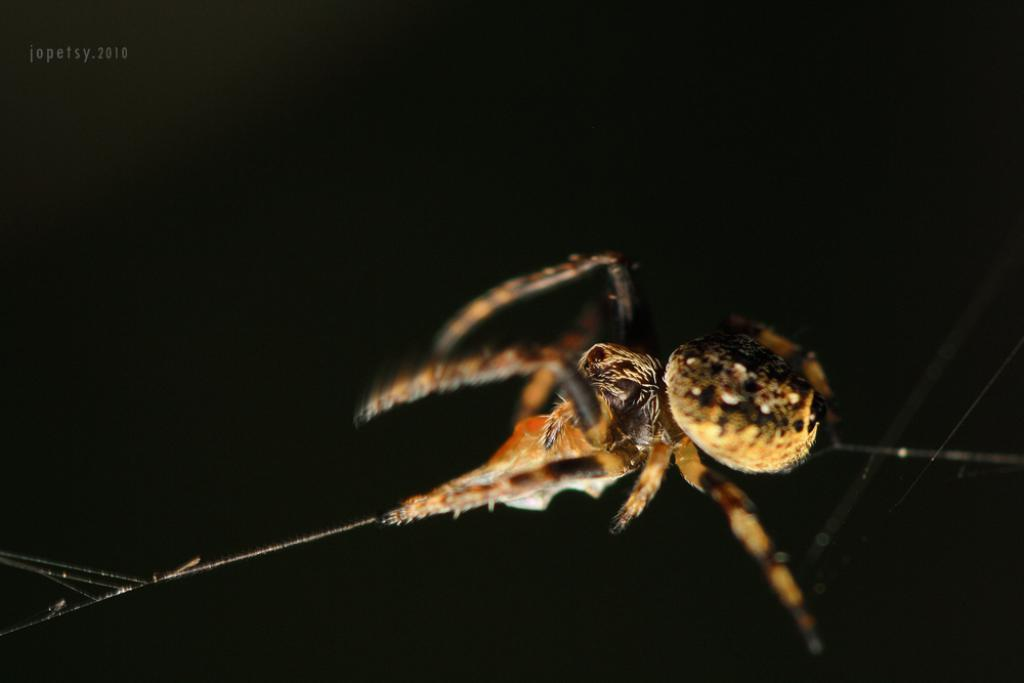What is the main subject of the image? The main subject of the image is a spider. What is the spider doing in the image? The spider is hanging in the air. Does the spider have any additional features in the image? Yes, the spider has a web on either side. What type of pie is being served at the spider's web in the image? There is no pie present in the image; it features a spider with webs on either side. How does the spider's web system work in the image? The image does not provide information about the spider's web system, as it only shows the spider hanging in the air with webs on either side. 